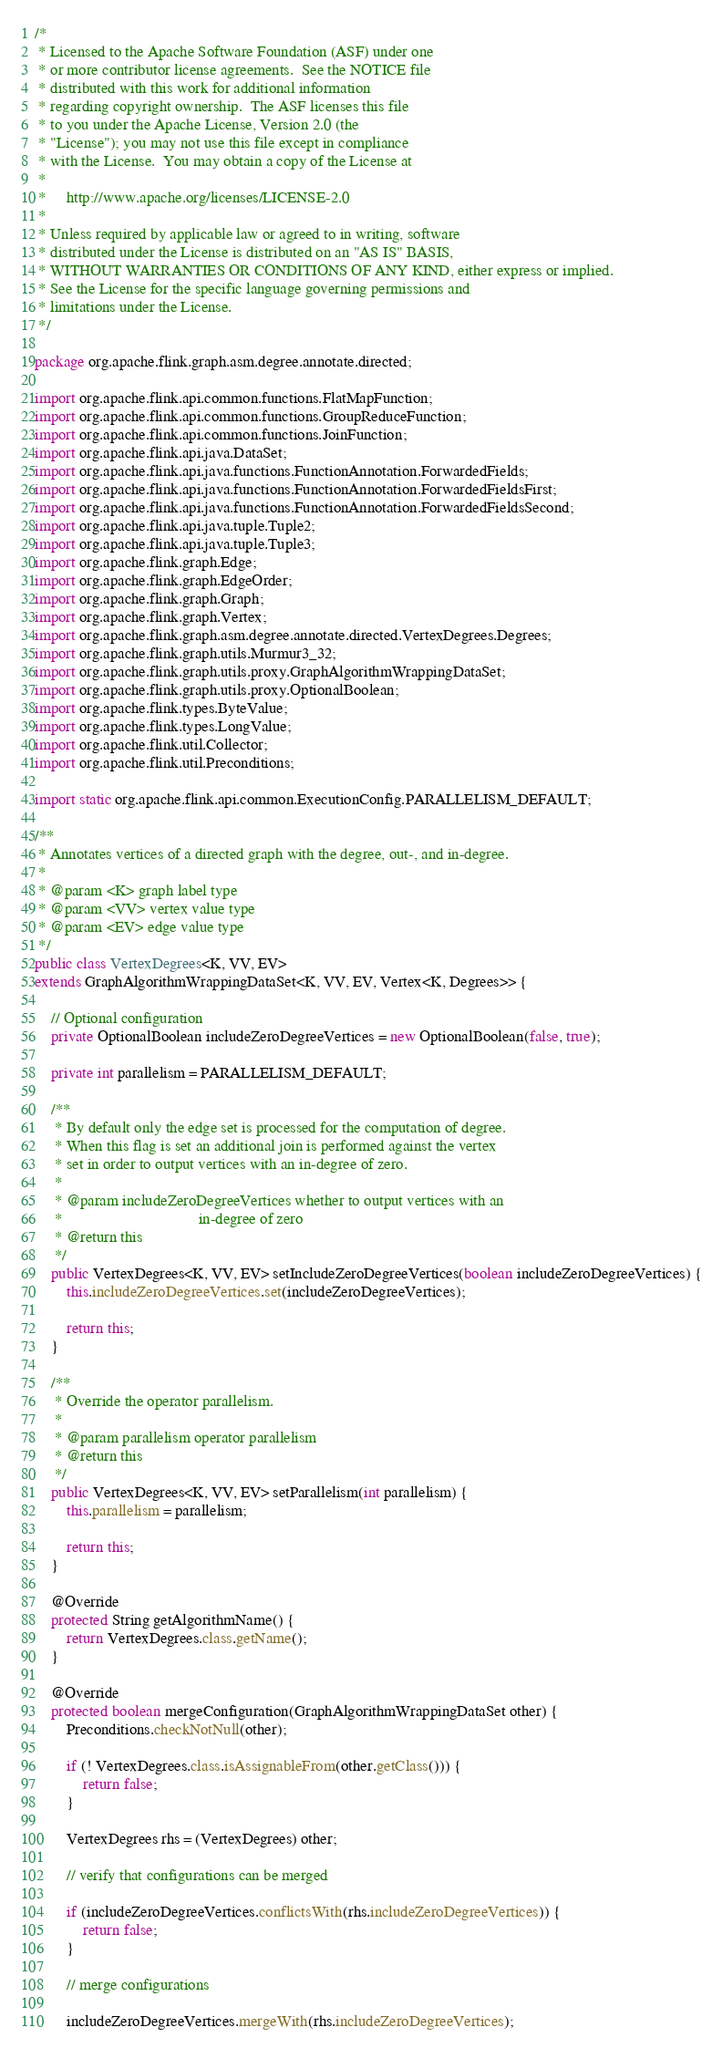Convert code to text. <code><loc_0><loc_0><loc_500><loc_500><_Java_>/*
 * Licensed to the Apache Software Foundation (ASF) under one
 * or more contributor license agreements.  See the NOTICE file
 * distributed with this work for additional information
 * regarding copyright ownership.  The ASF licenses this file
 * to you under the Apache License, Version 2.0 (the
 * "License"); you may not use this file except in compliance
 * with the License.  You may obtain a copy of the License at
 *
 *     http://www.apache.org/licenses/LICENSE-2.0
 *
 * Unless required by applicable law or agreed to in writing, software
 * distributed under the License is distributed on an "AS IS" BASIS,
 * WITHOUT WARRANTIES OR CONDITIONS OF ANY KIND, either express or implied.
 * See the License for the specific language governing permissions and
 * limitations under the License.
 */

package org.apache.flink.graph.asm.degree.annotate.directed;

import org.apache.flink.api.common.functions.FlatMapFunction;
import org.apache.flink.api.common.functions.GroupReduceFunction;
import org.apache.flink.api.common.functions.JoinFunction;
import org.apache.flink.api.java.DataSet;
import org.apache.flink.api.java.functions.FunctionAnnotation.ForwardedFields;
import org.apache.flink.api.java.functions.FunctionAnnotation.ForwardedFieldsFirst;
import org.apache.flink.api.java.functions.FunctionAnnotation.ForwardedFieldsSecond;
import org.apache.flink.api.java.tuple.Tuple2;
import org.apache.flink.api.java.tuple.Tuple3;
import org.apache.flink.graph.Edge;
import org.apache.flink.graph.EdgeOrder;
import org.apache.flink.graph.Graph;
import org.apache.flink.graph.Vertex;
import org.apache.flink.graph.asm.degree.annotate.directed.VertexDegrees.Degrees;
import org.apache.flink.graph.utils.Murmur3_32;
import org.apache.flink.graph.utils.proxy.GraphAlgorithmWrappingDataSet;
import org.apache.flink.graph.utils.proxy.OptionalBoolean;
import org.apache.flink.types.ByteValue;
import org.apache.flink.types.LongValue;
import org.apache.flink.util.Collector;
import org.apache.flink.util.Preconditions;

import static org.apache.flink.api.common.ExecutionConfig.PARALLELISM_DEFAULT;

/**
 * Annotates vertices of a directed graph with the degree, out-, and in-degree.
 *
 * @param <K> graph label type
 * @param <VV> vertex value type
 * @param <EV> edge value type
 */
public class VertexDegrees<K, VV, EV>
extends GraphAlgorithmWrappingDataSet<K, VV, EV, Vertex<K, Degrees>> {

	// Optional configuration
	private OptionalBoolean includeZeroDegreeVertices = new OptionalBoolean(false, true);

	private int parallelism = PARALLELISM_DEFAULT;

	/**
	 * By default only the edge set is processed for the computation of degree.
	 * When this flag is set an additional join is performed against the vertex
	 * set in order to output vertices with an in-degree of zero.
	 *
	 * @param includeZeroDegreeVertices whether to output vertices with an
	 *                                  in-degree of zero
	 * @return this
	 */
	public VertexDegrees<K, VV, EV> setIncludeZeroDegreeVertices(boolean includeZeroDegreeVertices) {
		this.includeZeroDegreeVertices.set(includeZeroDegreeVertices);

		return this;
	}

	/**
	 * Override the operator parallelism.
	 *
	 * @param parallelism operator parallelism
	 * @return this
	 */
	public VertexDegrees<K, VV, EV> setParallelism(int parallelism) {
		this.parallelism = parallelism;

		return this;
	}

	@Override
	protected String getAlgorithmName() {
		return VertexDegrees.class.getName();
	}

	@Override
	protected boolean mergeConfiguration(GraphAlgorithmWrappingDataSet other) {
		Preconditions.checkNotNull(other);

		if (! VertexDegrees.class.isAssignableFrom(other.getClass())) {
			return false;
		}

		VertexDegrees rhs = (VertexDegrees) other;

		// verify that configurations can be merged

		if (includeZeroDegreeVertices.conflictsWith(rhs.includeZeroDegreeVertices)) {
			return false;
		}

		// merge configurations

		includeZeroDegreeVertices.mergeWith(rhs.includeZeroDegreeVertices);</code> 